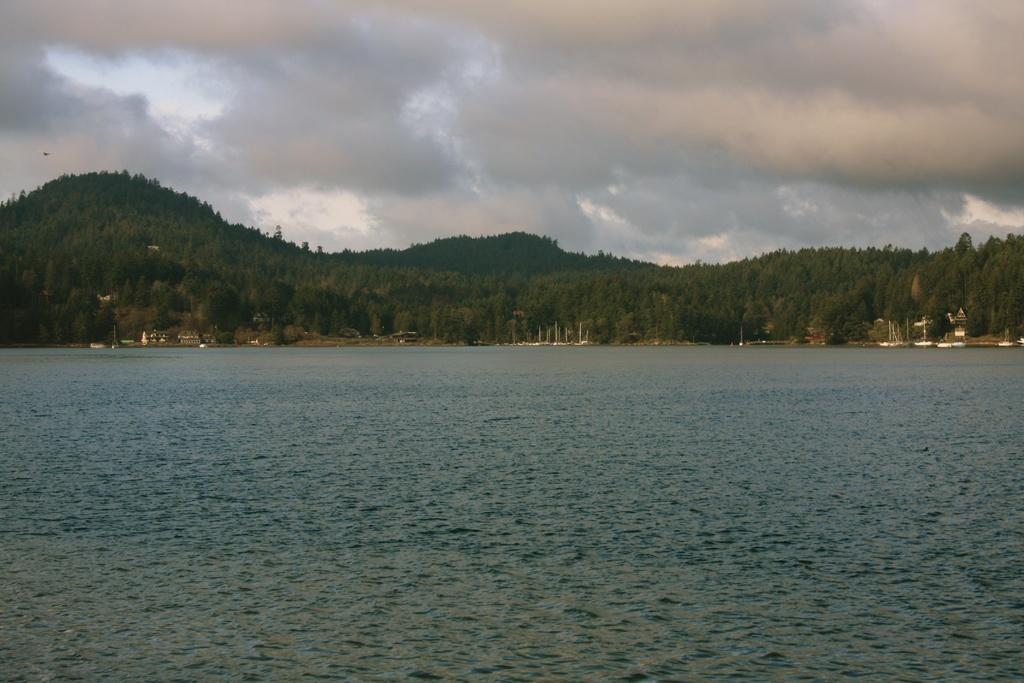What is the primary element present in the image? There is water in the image. What other natural elements can be seen in the image? There are trees and hills in the image. Are there any man-made structures visible? Yes, there are buildings in the image. What is visible in the background of the image? The sky is visible in the image, along with clouds. What type of seat can be seen in the water in the image? There are no seats present in the water in the image. Can you describe the veins of the trees in the image? There is no mention of veins in the image, as it focuses on the overall appearance of the trees and their leaves. 